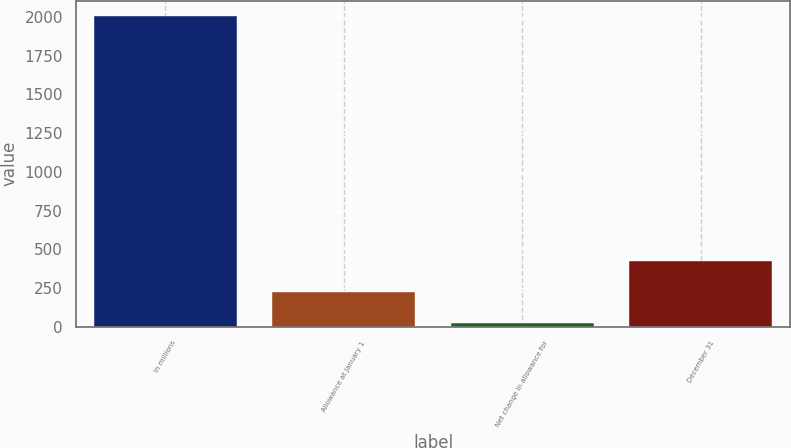Convert chart to OTSL. <chart><loc_0><loc_0><loc_500><loc_500><bar_chart><fcel>In millions<fcel>Allowance at January 1<fcel>Net change in allowance for<fcel>December 31<nl><fcel>2005<fcel>223<fcel>25<fcel>421<nl></chart> 